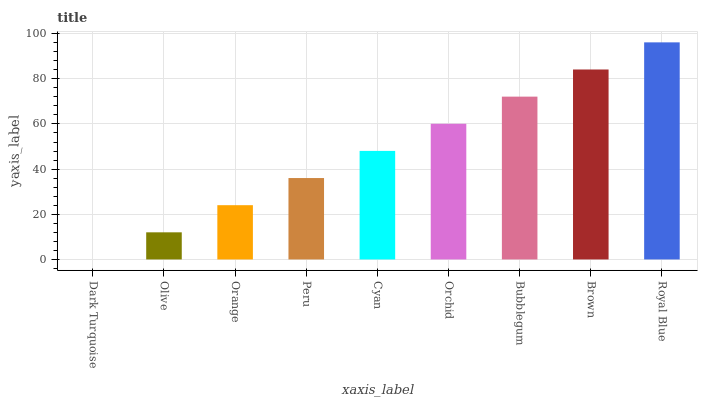Is Olive the minimum?
Answer yes or no. No. Is Olive the maximum?
Answer yes or no. No. Is Olive greater than Dark Turquoise?
Answer yes or no. Yes. Is Dark Turquoise less than Olive?
Answer yes or no. Yes. Is Dark Turquoise greater than Olive?
Answer yes or no. No. Is Olive less than Dark Turquoise?
Answer yes or no. No. Is Cyan the high median?
Answer yes or no. Yes. Is Cyan the low median?
Answer yes or no. Yes. Is Brown the high median?
Answer yes or no. No. Is Olive the low median?
Answer yes or no. No. 